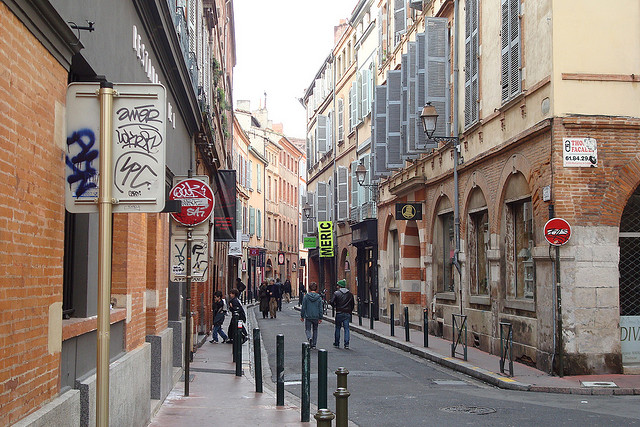<image>Are there cars on the street? There are no cars on the street. Are there cars on the street? There are no cars on the street. 